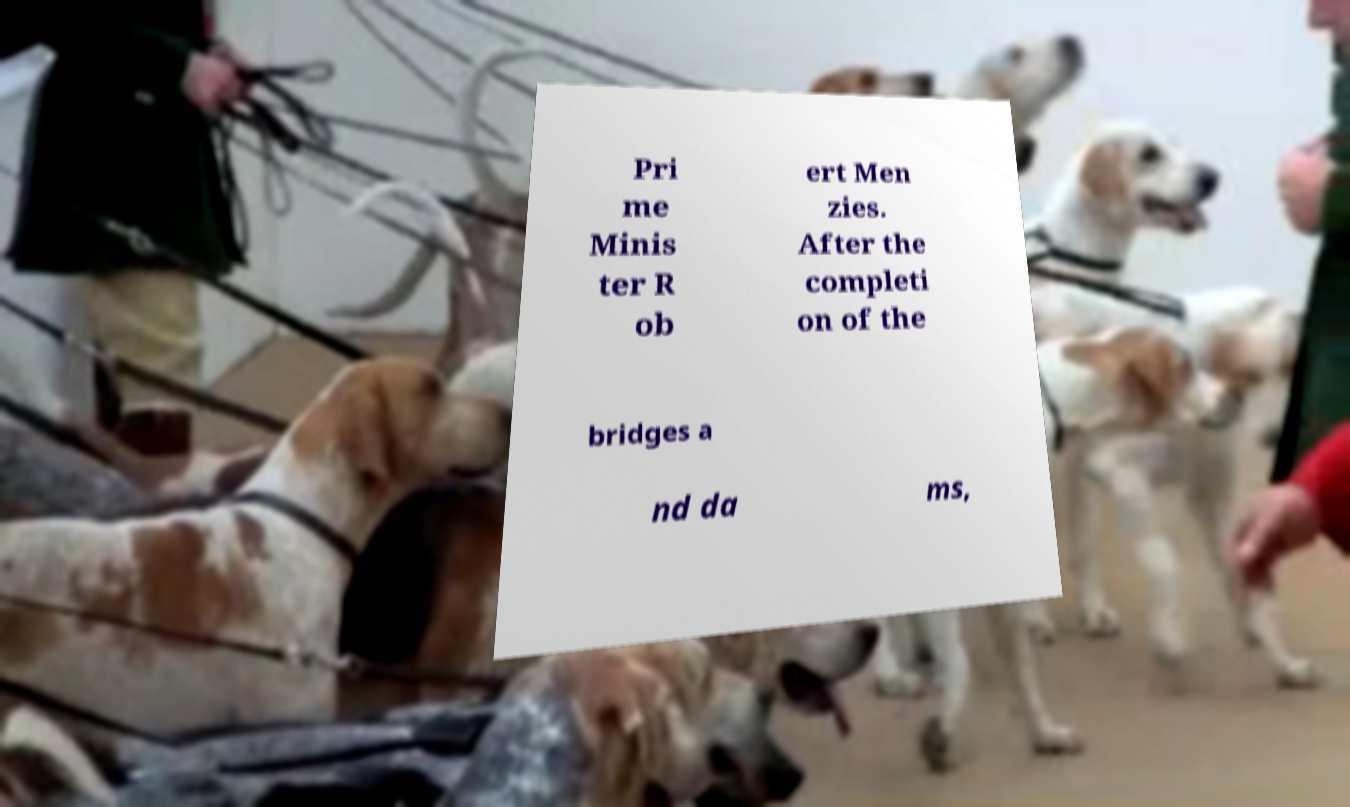Please identify and transcribe the text found in this image. Pri me Minis ter R ob ert Men zies. After the completi on of the bridges a nd da ms, 